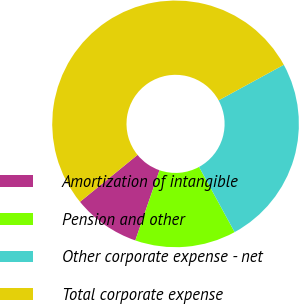Convert chart to OTSL. <chart><loc_0><loc_0><loc_500><loc_500><pie_chart><fcel>Amortization of intangible<fcel>Pension and other<fcel>Other corporate expense - net<fcel>Total corporate expense<nl><fcel>8.82%<fcel>13.24%<fcel>25.0%<fcel>52.94%<nl></chart> 